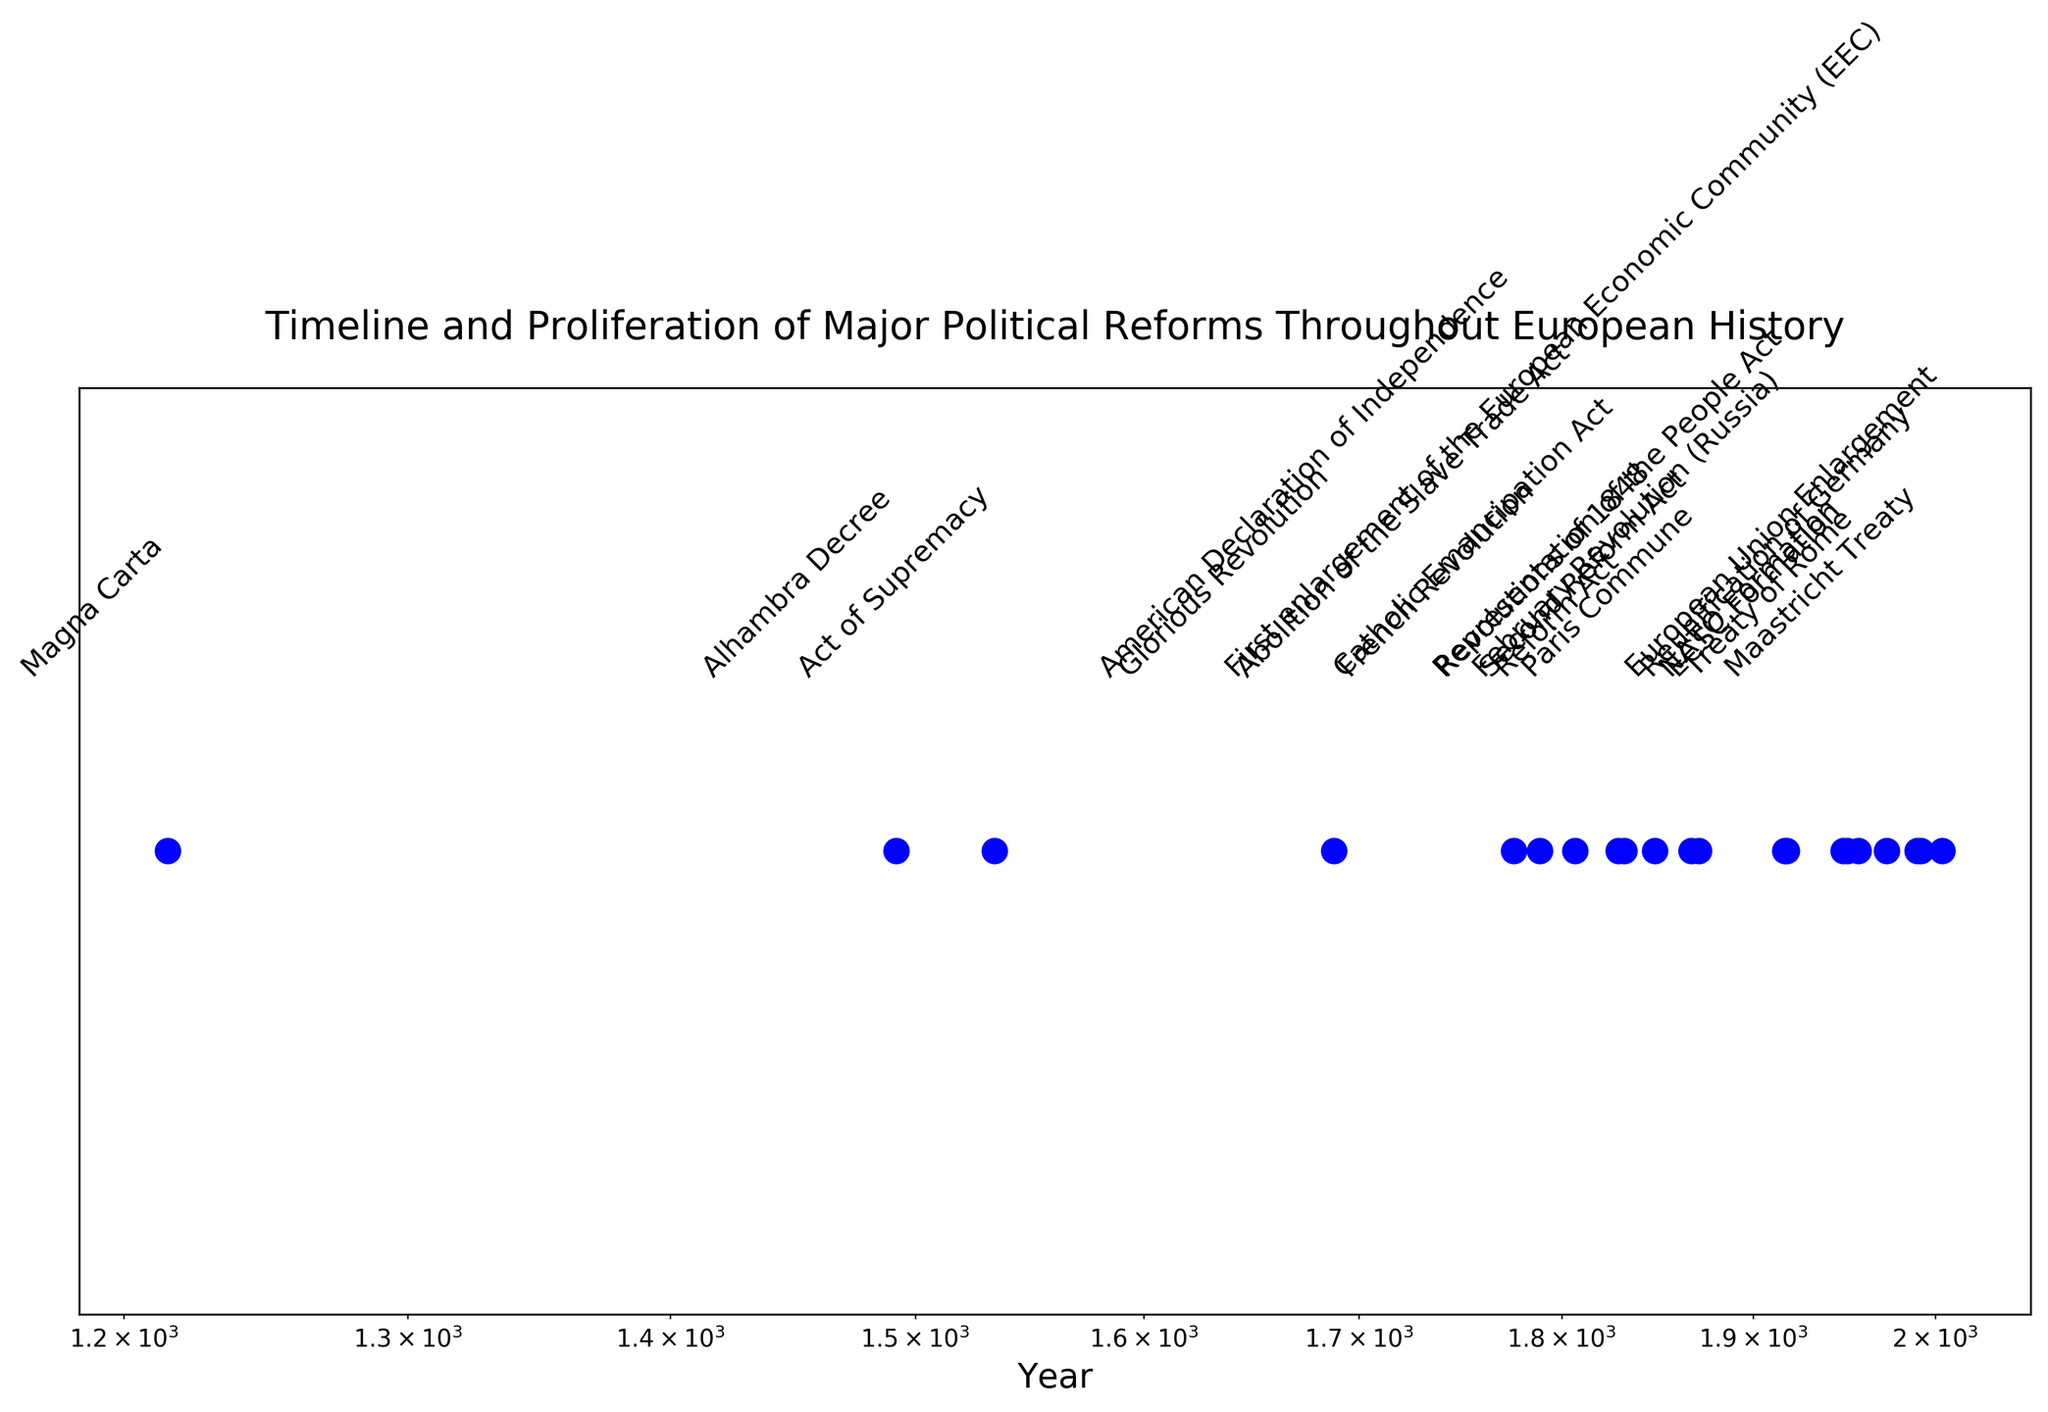Which political reform occurred earliest? The figure lists the political reforms in chronological order on a log-scale x-axis. The earliest point on the left side of the x-axis represents the Magna Carta in 1215.
Answer: Magna Carta Which political reform happened just before the Abolition of the Slave Trade Act? Locate the year 1807 for the Abolition of the Slave Trade Act and look directly to its left for the next closest reform. The Act of Supremacy in 1534 is the previous reform.
Answer: Act of Supremacy What is the median political reform based on the timeline? There are 21 reforms in the list. To determine the median, identify the 11th reform. Count the reforms from the left (earliest) to the right (latest) to find the median. The 11th reform is the Second Reform Act in 1867.
Answer: Second Reform Act How many political reforms occurred after the French Revolution? Locate the French Revolution in 1789 on the x-axis. Count the number of reforms that appear to the right of this point. There are 13 reforms listed after the French Revolution in 1789.
Answer: 13 Which political reform is closer to NATO Formation: the Representation of the People Act or the Paris Commune? Find the point for NATO Formation in 1949. Look to see which reform is closer by comparing the distances on the log-scale x-axis. The Representation of the People Act in 1918 is closer to 1949 than the Paris Commune in 1871.
Answer: Representation of the People Act Which two political reforms are closest together in time? Examine the x-axis and identify the shortest distance between two points. The Maastricht Treaty in 1992 is very close to the European Union Enlargement in 2004, but the closest are the ECSC Formation in 1951 and the Treaty of Rome in 1957.
Answer: ECSC Formation and Treaty of Rome What is the average year of the political reforms listed from 1800 onwards? Identify the reforms from 1800 onwards: Abolition of the Slave Trade Act (1807), Catholic Emancipation Act (1829), and so forth. Sum the years and divide by the count (13 reforms). The average year is calculated as follows: (1807 + 1829 + 1832 + 1848 + 1867 + 1871 + 1917 + 1918 + 1949 + 1951 + 1957 + 1973 + 1990 + 1992 + 2004) / 15 = 1922.67.
Answer: 1922.67 Which two political reforms mark the beginning and end of the 19th century reforms? The 19th-century reforms are those between 1800 and 1899. The earliest is Abolition of the Slave Trade Act (1807), and the latest is the Paris Commune (1871).
Answer: Abolition of the Slave Trade Act and Paris Commune 